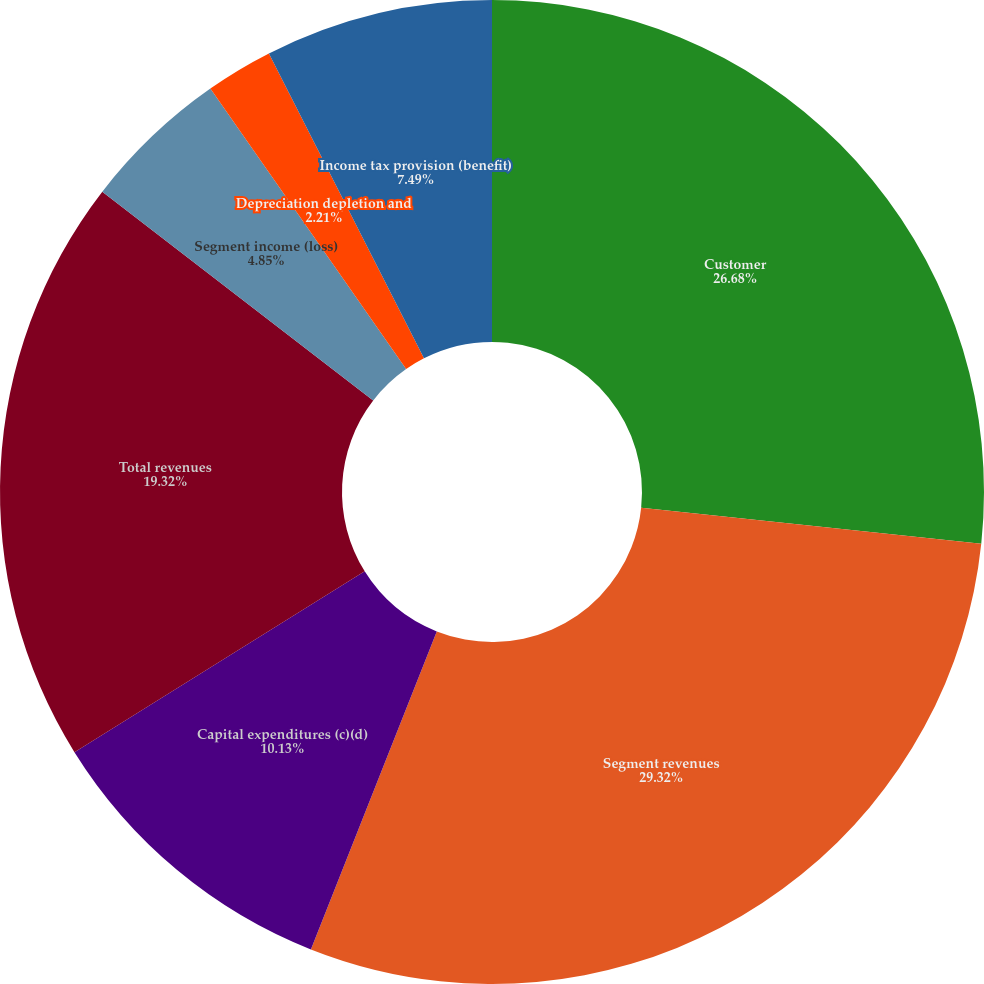Convert chart to OTSL. <chart><loc_0><loc_0><loc_500><loc_500><pie_chart><fcel>Customer<fcel>Segment revenues<fcel>Capital expenditures (c)(d)<fcel>Total revenues<fcel>Segment income (loss)<fcel>Depreciation depletion and<fcel>Income tax provision (benefit)<nl><fcel>26.68%<fcel>29.32%<fcel>10.13%<fcel>19.32%<fcel>4.85%<fcel>2.21%<fcel>7.49%<nl></chart> 